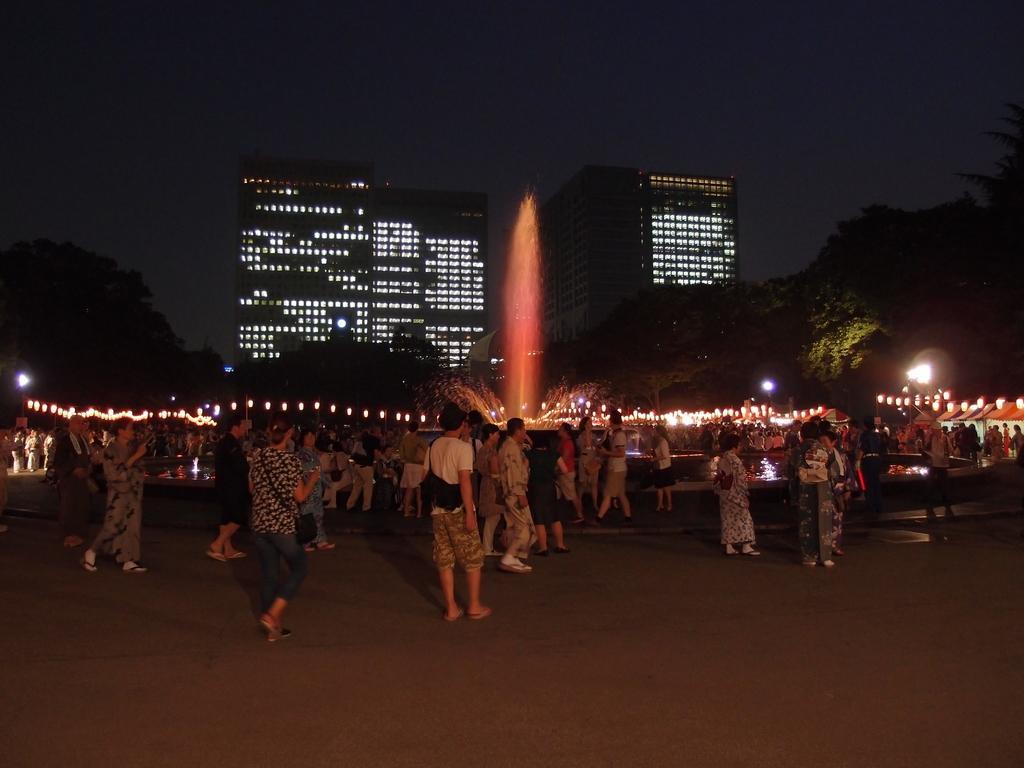Can you describe this image briefly? In this image we can see a few people standing, there are some buildings, lights, poles, trees and a water fountain. 